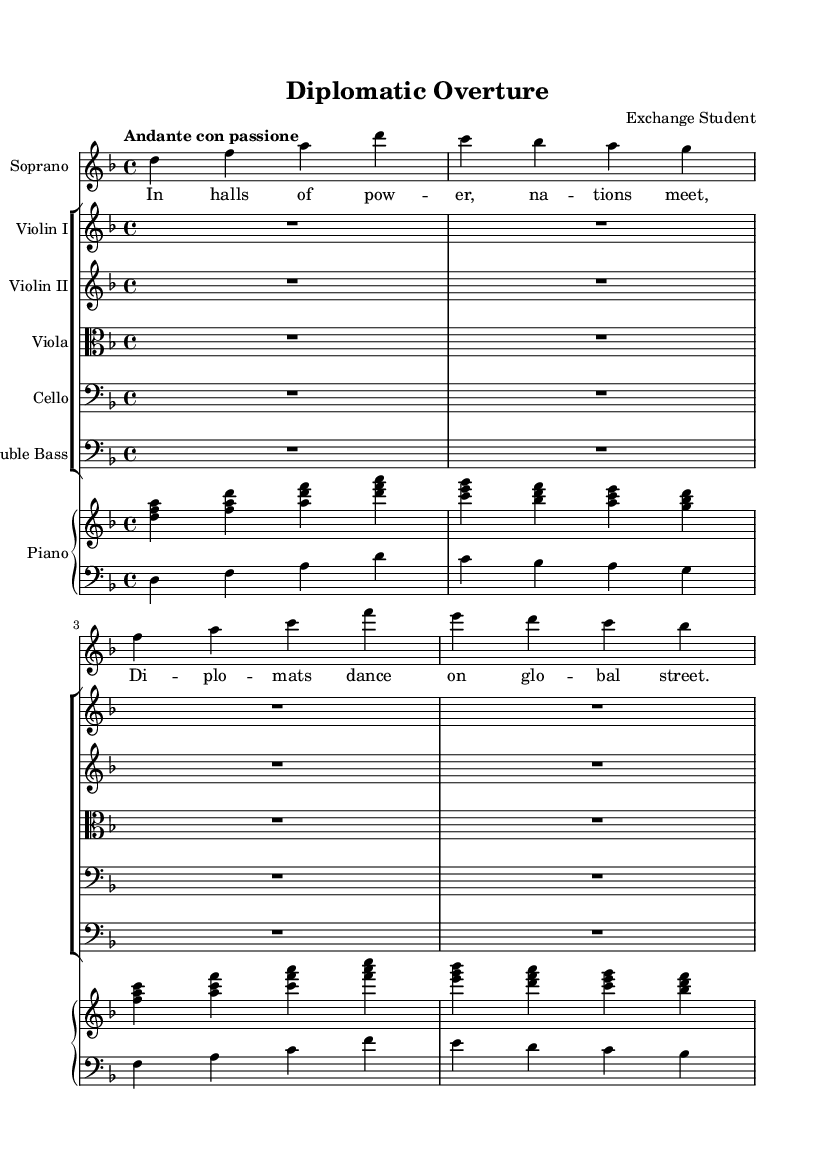What is the key signature of this music? The key signature is found at the beginning of the staff. Here, there is one flat, which indicates D minor or F major. In this context, it is primarily in D minor.
Answer: D minor What is the time signature of this music? The time signature is specified at the beginning of the score as 4/4, which means there are four beats in each measure and the quarter note receives one beat.
Answer: 4/4 What is the tempo marking for this music? The tempo is indicated at the beginning of the piece as "Andante con passione," which suggests a moderately slow pace, played with passion.
Answer: Andante con passione How many instruments are there in total in this score? By counting the parts listed in the score, we see one soprano, five string instruments (Violin I, Violin II, Viola, Cello, Double Bass), and a piano, totaling seven instruments.
Answer: Seven What voice part is featured in this piece? The voice part presented in the score is labeled as "Soprano," which indicates the highest vocal range typically used in this type of music.
Answer: Soprano Which poetic theme is explored in the lyrics of the soprano voice? The lyrics reference power and international diplomacy, as seen in phrases like "In halls of power, nations meet," indicating a theme of global interactions.
Answer: Diplomacy 